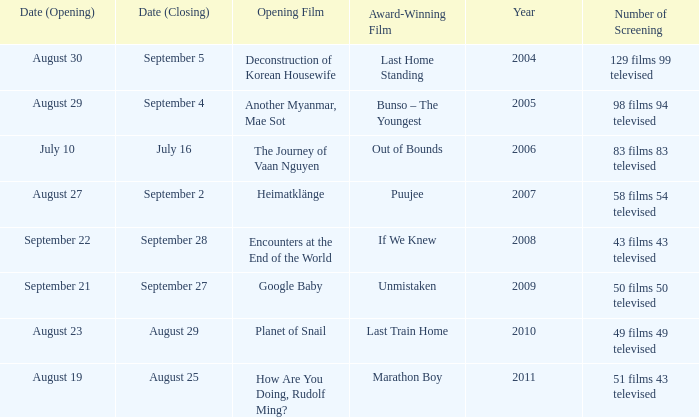Which award-winning film has a closing date of September 4? Bunso – The Youngest. 